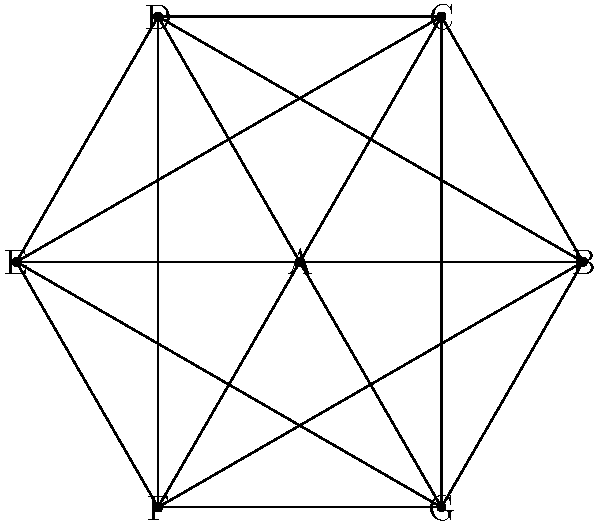As the head of the Kîkan tribe, you are tasked with creating a map that represents the lands of seven neighboring tribes, including your own. The map is represented by the graph above, where each vertex represents a tribal land and each edge indicates that two lands share a border. What is the minimum number of colors needed to color this map so that no two adjacent lands have the same color? To determine the minimum number of colors needed (chromatic number), we can follow these steps:

1. Observe that the graph is a complete graph $K_7$, where every vertex is connected to every other vertex.

2. In a complete graph $K_n$, each vertex is adjacent to all other $n-1$ vertices.

3. Therefore, each vertex must have a unique color, as it is adjacent to all other vertices.

4. The chromatic number of a complete graph $K_n$ is always equal to $n$.

5. In this case, we have $K_7$, so the chromatic number is 7.

6. This means we need at least 7 different colors to properly color the map, ensuring no two adjacent lands have the same color.

This concept is deeply rooted in the Four Color Theorem, which states that any planar map can be colored with at most four colors. However, our map is not planar, as it represents a more complex tribal land arrangement, requiring more colors.
Answer: 7 colors 